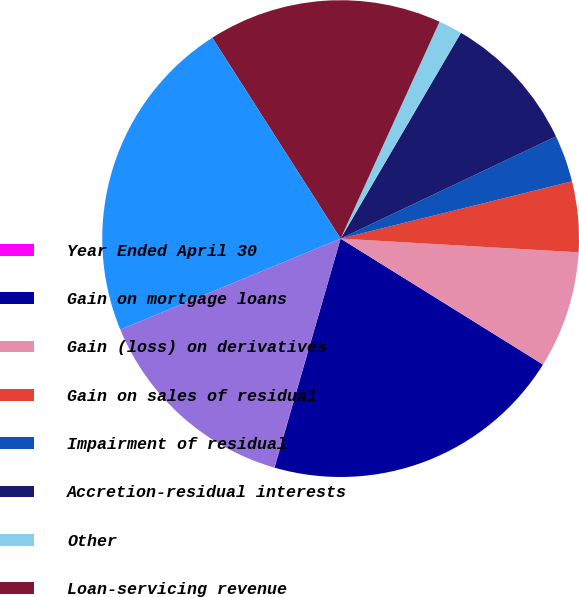Convert chart. <chart><loc_0><loc_0><loc_500><loc_500><pie_chart><fcel>Year Ended April 30<fcel>Gain on mortgage loans<fcel>Gain (loss) on derivatives<fcel>Gain on sales of residual<fcel>Impairment of residual<fcel>Accretion-residual interests<fcel>Other<fcel>Loan-servicing revenue<fcel>Total revenues<fcel>Cost of services<nl><fcel>0.03%<fcel>20.61%<fcel>7.94%<fcel>4.78%<fcel>3.19%<fcel>9.53%<fcel>1.61%<fcel>15.86%<fcel>22.19%<fcel>14.27%<nl></chart> 